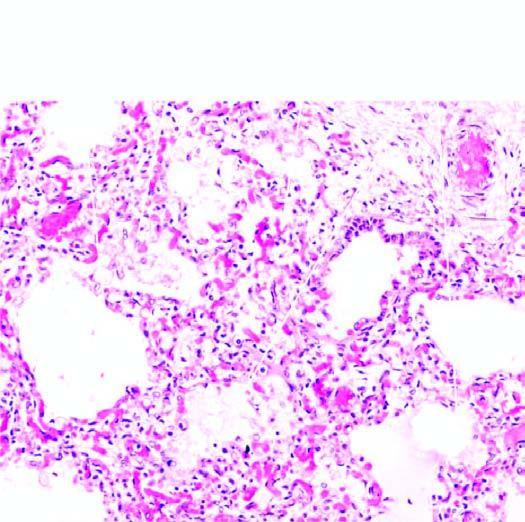s a congestion of septal walls while the air spaces contain pale oedema fluid and a few red cells?
Answer the question using a single word or phrase. No 